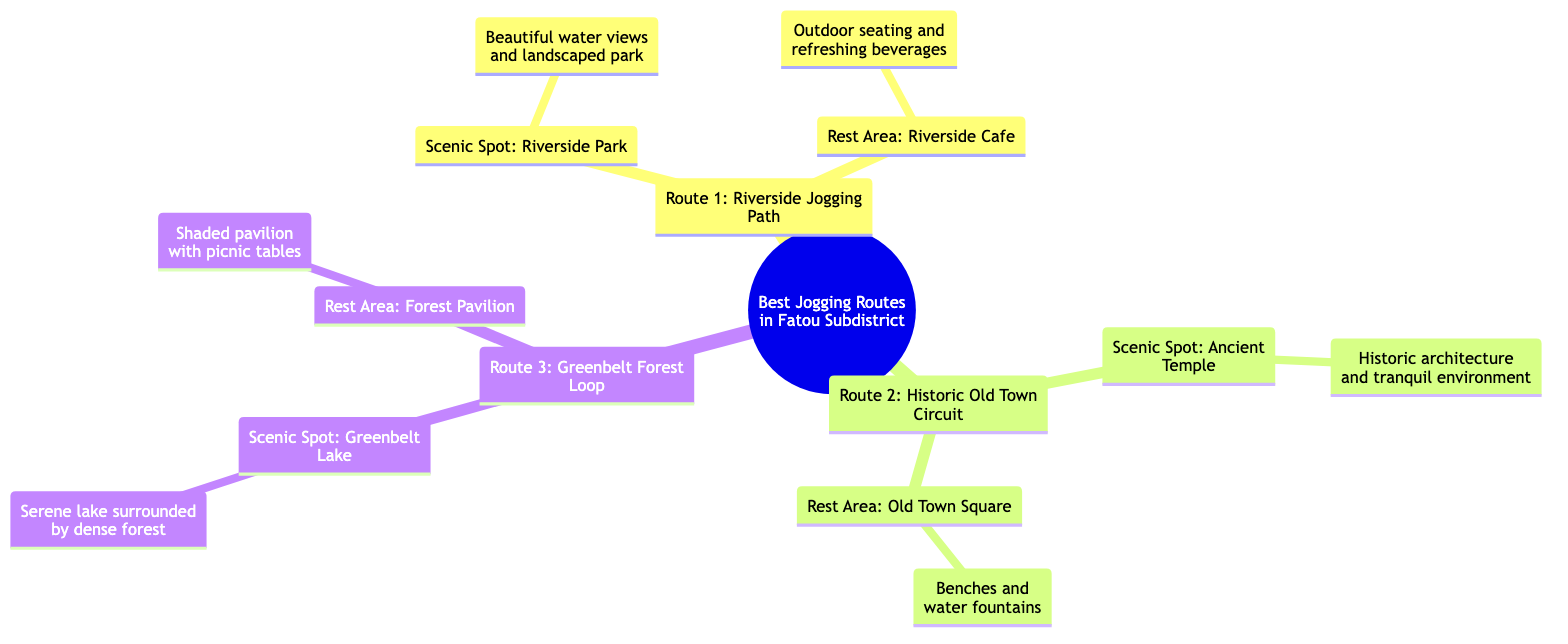What is the first route listed in the diagram? The diagram lists the routes in a specific order. The first route mentioned is "Route 1: Riverside Jogging Path."
Answer: Route 1: Riverside Jogging Path How many scenic spots are detailed in the diagram? The diagram includes three routes, each with one scenic spot. Therefore, 3 scenic spots are detailed in total.
Answer: 3 scenic spots What type of seating is available at the rest area for Route 1? In the diagram, the rest area at Route 1 is referred to as "Riverside Cafe," which specifically mentions outdoor seating.
Answer: Outdoor seating Which route includes a rest area with picnic tables? Looking at the diagram, "Route 3: Greenbelt Forest Loop" contains a rest area called "Forest Pavilion," which has picnic tables.
Answer: Route 3: Greenbelt Forest Loop What is the scenic highlight of "Route 2"? The scenic spot listed for "Route 2: Historic Old Town Circuit" is the "Ancient Temple," which is described as having historic architecture and a tranquil environment.
Answer: Ancient Temple Which route offers a serene lake as a scenic spot? Examining the scenic spots of the routes, only "Route 3: Greenbelt Forest Loop" features the "Greenbelt Lake," identified as a serene lake surrounded by dense forest.
Answer: Route 3: Greenbelt Forest Loop What is the common feature of all the rest areas listed? Upon reviewing the rest areas in the diagram, it can be identified that all rest areas provide some form of seating or relaxation space.
Answer: Seating What scenic spot is noted for its water views? The "Riverside Park," located along "Route 1," is the scenic spot mentioned in the diagram that provides beautiful water views.
Answer: Riverside Park Which route is associated with the Old Town Square? The diagram indicates that "Route 2: Historic Old Town Circuit" contains the rest area known as "Old Town Square."
Answer: Route 2: Historic Old Town Circuit 